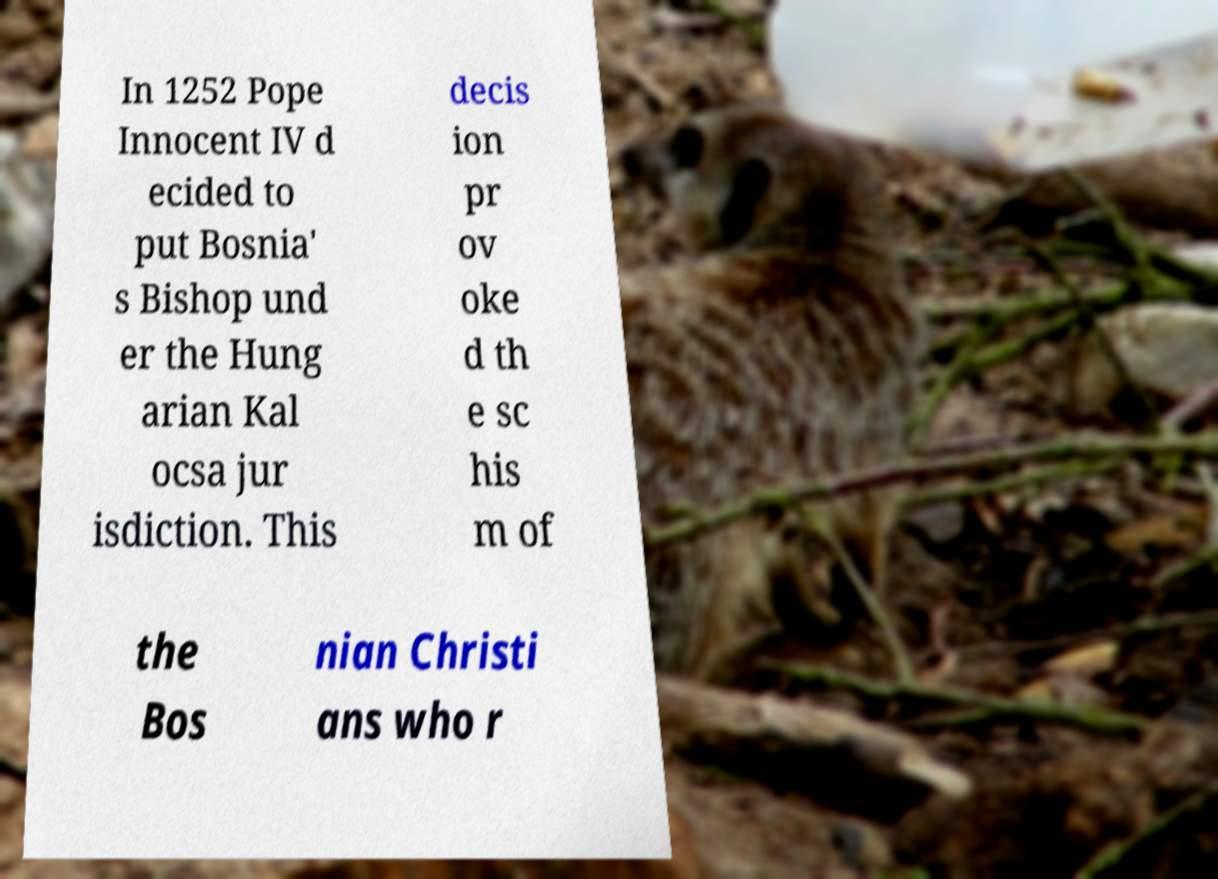For documentation purposes, I need the text within this image transcribed. Could you provide that? In 1252 Pope Innocent IV d ecided to put Bosnia' s Bishop und er the Hung arian Kal ocsa jur isdiction. This decis ion pr ov oke d th e sc his m of the Bos nian Christi ans who r 